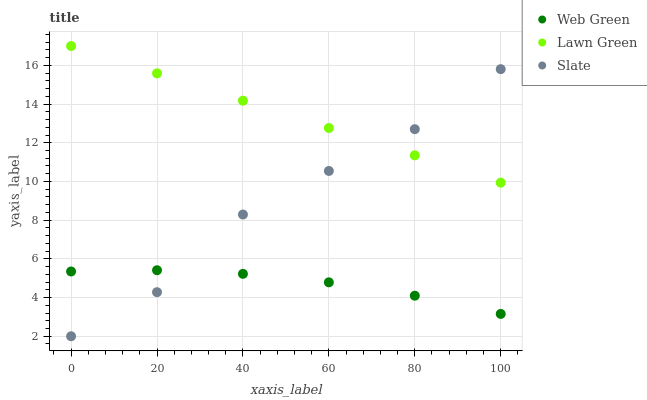Does Web Green have the minimum area under the curve?
Answer yes or no. Yes. Does Lawn Green have the maximum area under the curve?
Answer yes or no. Yes. Does Slate have the minimum area under the curve?
Answer yes or no. No. Does Slate have the maximum area under the curve?
Answer yes or no. No. Is Lawn Green the smoothest?
Answer yes or no. Yes. Is Slate the roughest?
Answer yes or no. Yes. Is Web Green the smoothest?
Answer yes or no. No. Is Web Green the roughest?
Answer yes or no. No. Does Slate have the lowest value?
Answer yes or no. Yes. Does Web Green have the lowest value?
Answer yes or no. No. Does Lawn Green have the highest value?
Answer yes or no. Yes. Does Slate have the highest value?
Answer yes or no. No. Is Web Green less than Lawn Green?
Answer yes or no. Yes. Is Lawn Green greater than Web Green?
Answer yes or no. Yes. Does Slate intersect Lawn Green?
Answer yes or no. Yes. Is Slate less than Lawn Green?
Answer yes or no. No. Is Slate greater than Lawn Green?
Answer yes or no. No. Does Web Green intersect Lawn Green?
Answer yes or no. No. 